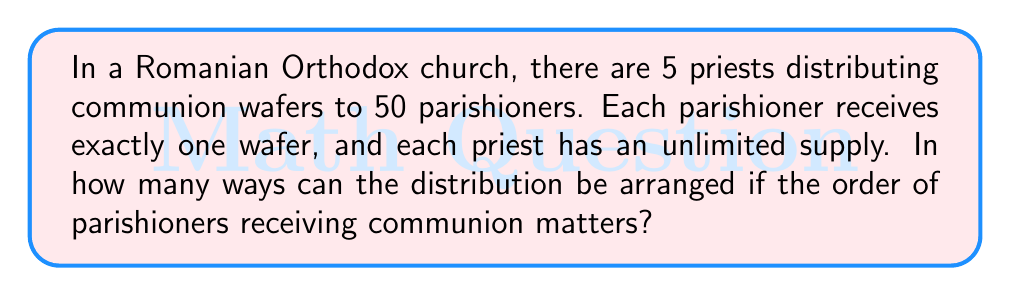Teach me how to tackle this problem. Let's approach this step-by-step:

1) For each parishioner, we need to choose which of the 5 priests will give them a communion wafer.

2) This is a sequence of 50 choices, where each choice is independent and has 5 options.

3) This scenario fits the multiplication principle of counting.

4) In such cases, we multiply the number of options for each choice:
   $$5 \times 5 \times 5 \times ... \text{ (50 times) }$$

5) This can be written as an exponent:
   $$5^{50}$$

6) This large number represents all possible ways the 50 parishioners can receive communion from the 5 priests, considering the order of parishioners.

7) We don't need to calculate this number explicitly, as the question asks for the number of ways, not the actual numerical value.
Answer: $5^{50}$ 